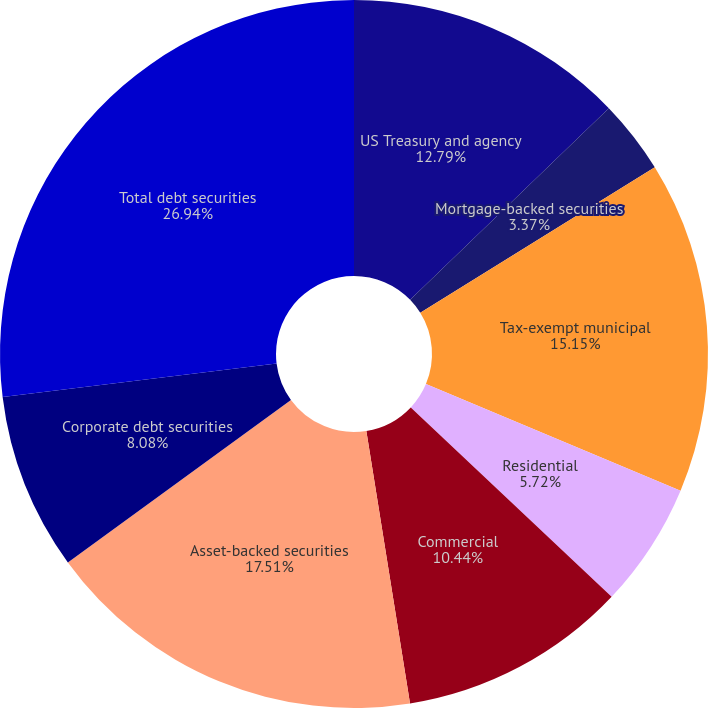<chart> <loc_0><loc_0><loc_500><loc_500><pie_chart><fcel>US Treasury and agency<fcel>Mortgage-backed securities<fcel>Tax-exempt municipal<fcel>Residential<fcel>Commercial<fcel>Asset-backed securities<fcel>Corporate debt securities<fcel>Total debt securities<nl><fcel>12.79%<fcel>3.37%<fcel>15.15%<fcel>5.72%<fcel>10.44%<fcel>17.51%<fcel>8.08%<fcel>26.94%<nl></chart> 